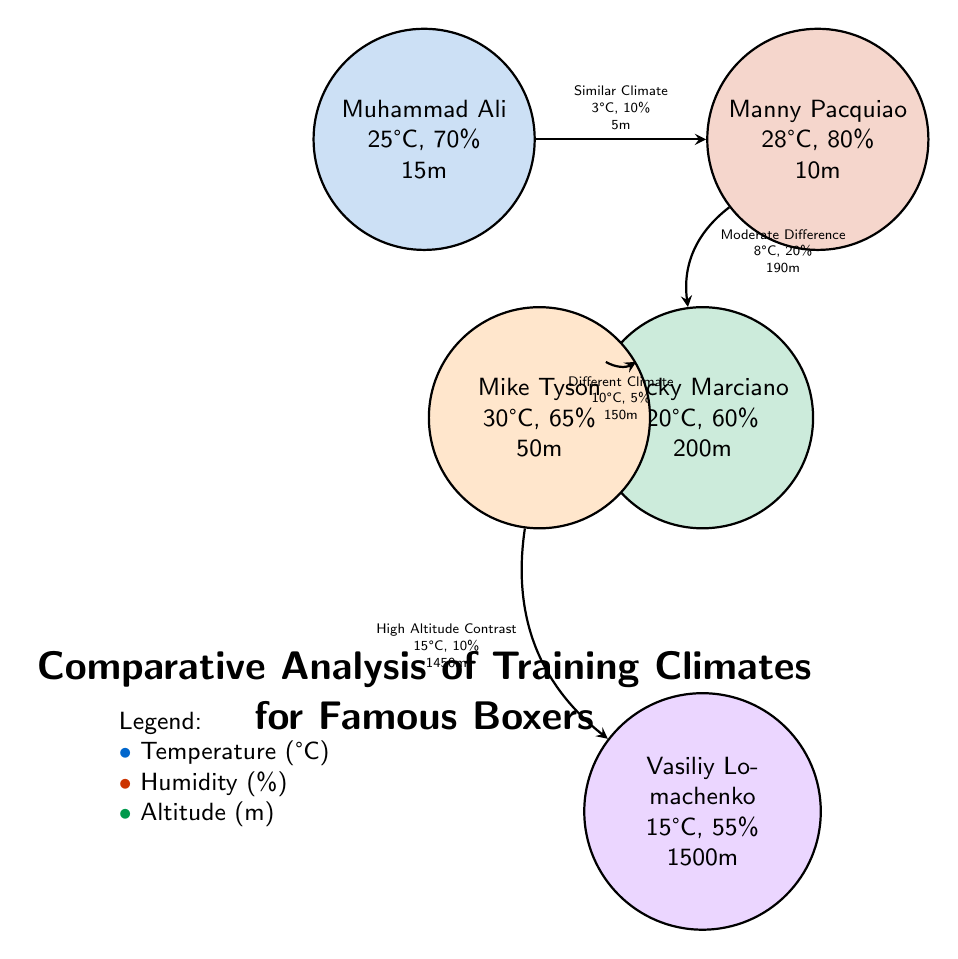What is the temperature of Muhammad Ali's training climate? The diagram indicates that Muhammad Ali's training climate has a temperature of 25°C, directly found in the node associated with him.
Answer: 25°C What is the humidity percentage in Manny Pacquiao's training climate? The node for Manny Pacquiao shows a humidity of 80%, retrieved directly from the information displayed in that node.
Answer: 80% How many boxers are represented in the diagram? The diagram features five distinct boxers, as indicated by the five nodes present in the diagram.
Answer: 5 What is the altitude of Vasiliy Lomachenko's training location? The altitude for Vasiliy Lomachenko is specified in the node as 1500m, which is explicitly stated in the diagram.
Answer: 1500m What is the relationship between Muhammad Ali and Manny Pacquiao's climates? The connection line between Muhammad Ali and Manny Pacquiao specifies "Similar Climate," indicating that their climates are closely related.
Answer: Similar Climate How does the humidity of Rocky Marciano's training climate compare to Mike Tyson's? Rocky Marciano's humidity is listed as 60% while Mike Tyson's humidity is 65%, showing that Mike Tyson's training climate has a higher humidity.
Answer: Higher What is the temperature difference between Mike Tyson and Rocky Marciano? The temperatures are 30°C for Mike Tyson and 20°C for Rocky Marciano, indicating a difference of 10°C. Thus, Mike Tyson’s climate is warmer.
Answer: 10°C Which boxer's climate is at the highest altitude? The diagram shows Vasiliy Lomachenko at an altitude of 1500m, which is the highest altitude among all boxers represented.
Answer: Vasiliy Lomachenko Which boxer has the most similar climate to Rocky Marciano? The connection from Rocky Marciano leads to Mike Tyson, which is described as "Moderate Difference," indicating a relatively close climate compared to the others.
Answer: Mike Tyson 